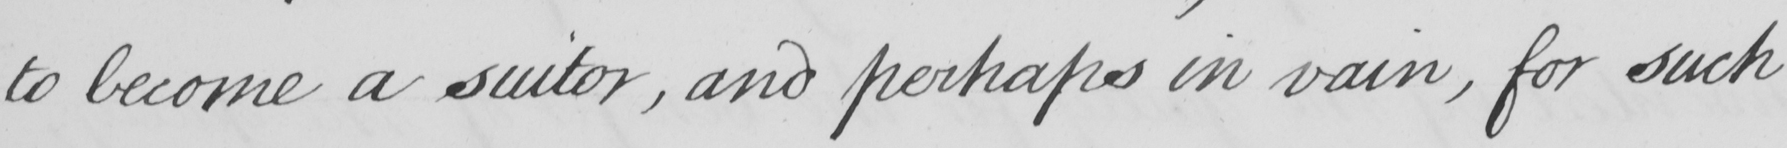Transcribe the text shown in this historical manuscript line. to become a suitor , and perhaps in vain , for such 